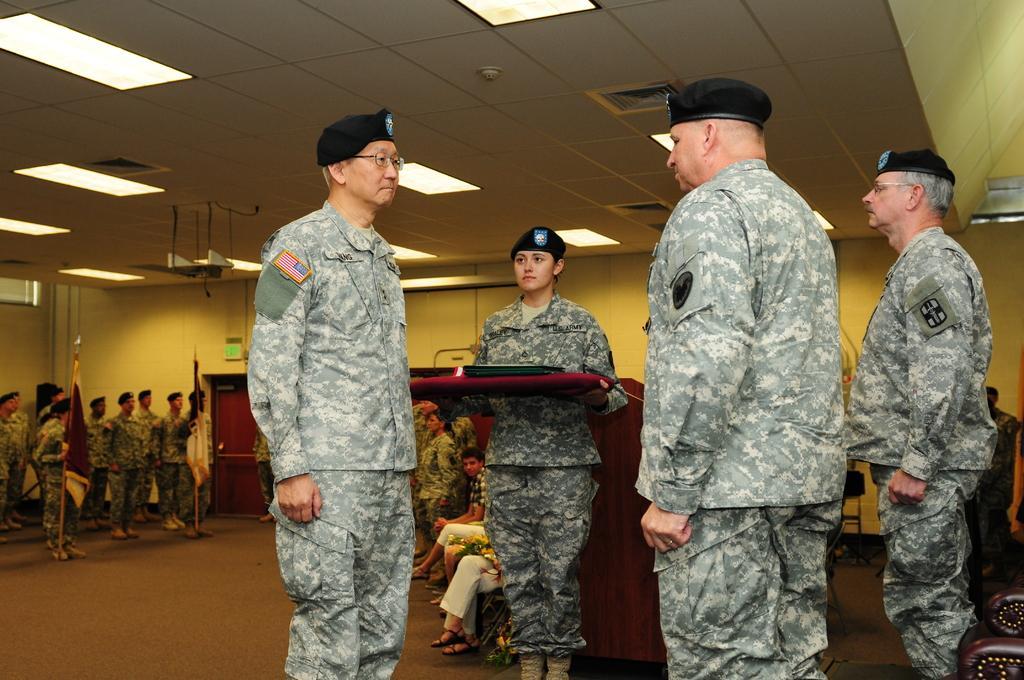Please provide a concise description of this image. In this image there are many people some are sitting and some are standing. There are flags. There are chairs and tables. 